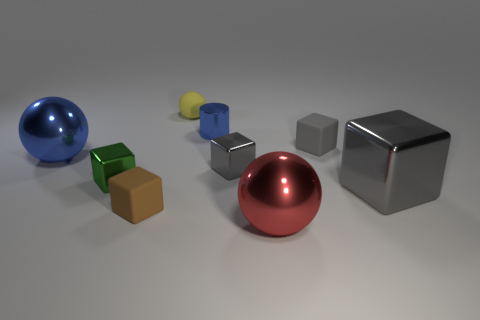Subtract all gray spheres. How many gray cubes are left? 3 Subtract all green cubes. How many cubes are left? 4 Subtract all green blocks. How many blocks are left? 4 Subtract all red cubes. Subtract all blue spheres. How many cubes are left? 5 Add 1 blue blocks. How many objects exist? 10 Subtract all balls. How many objects are left? 6 Add 4 metal blocks. How many metal blocks are left? 7 Add 6 red metal spheres. How many red metal spheres exist? 7 Subtract 1 brown cubes. How many objects are left? 8 Subtract all brown blocks. Subtract all blue metal things. How many objects are left? 6 